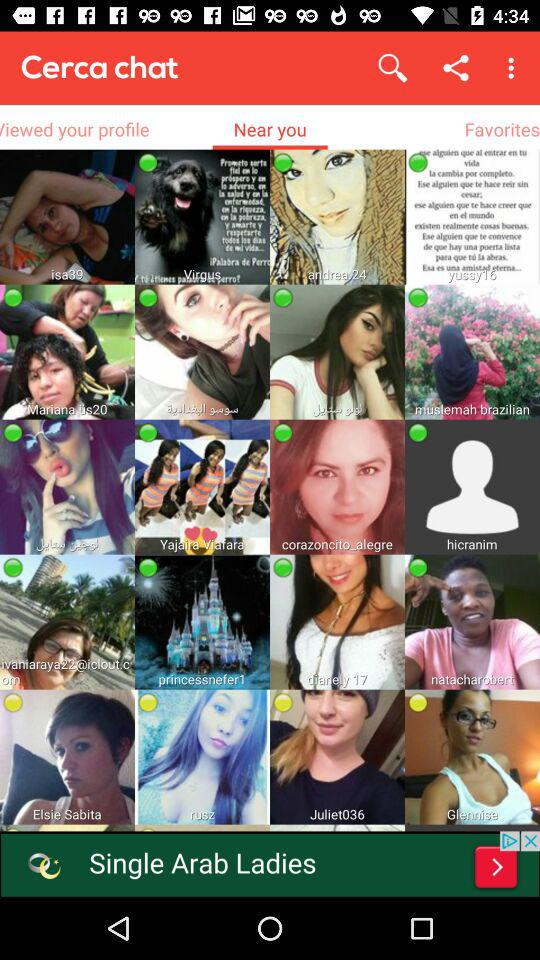What is the age of Isa?
When the provided information is insufficient, respond with <no answer>. <no answer> 